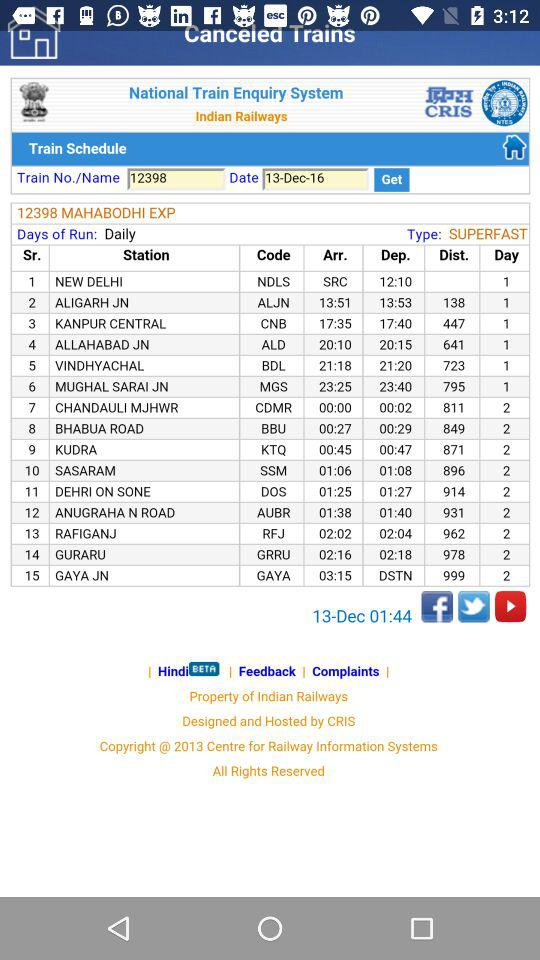What is the distance between "NEW DELHI" and "KANPUR CENTRAL"? The distance between "NEW DELHI" and "KANPUR CENTRAL" is 447. 